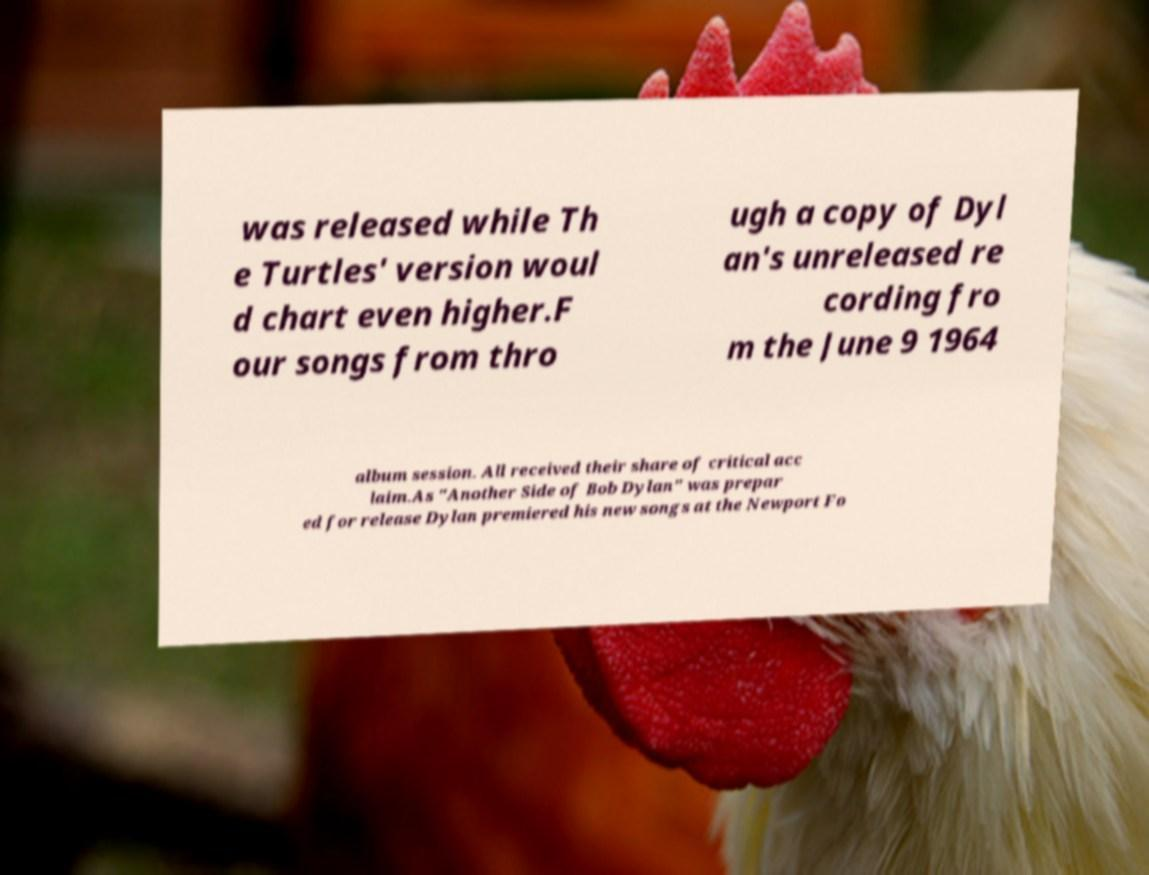For documentation purposes, I need the text within this image transcribed. Could you provide that? was released while Th e Turtles' version woul d chart even higher.F our songs from thro ugh a copy of Dyl an's unreleased re cording fro m the June 9 1964 album session. All received their share of critical acc laim.As "Another Side of Bob Dylan" was prepar ed for release Dylan premiered his new songs at the Newport Fo 